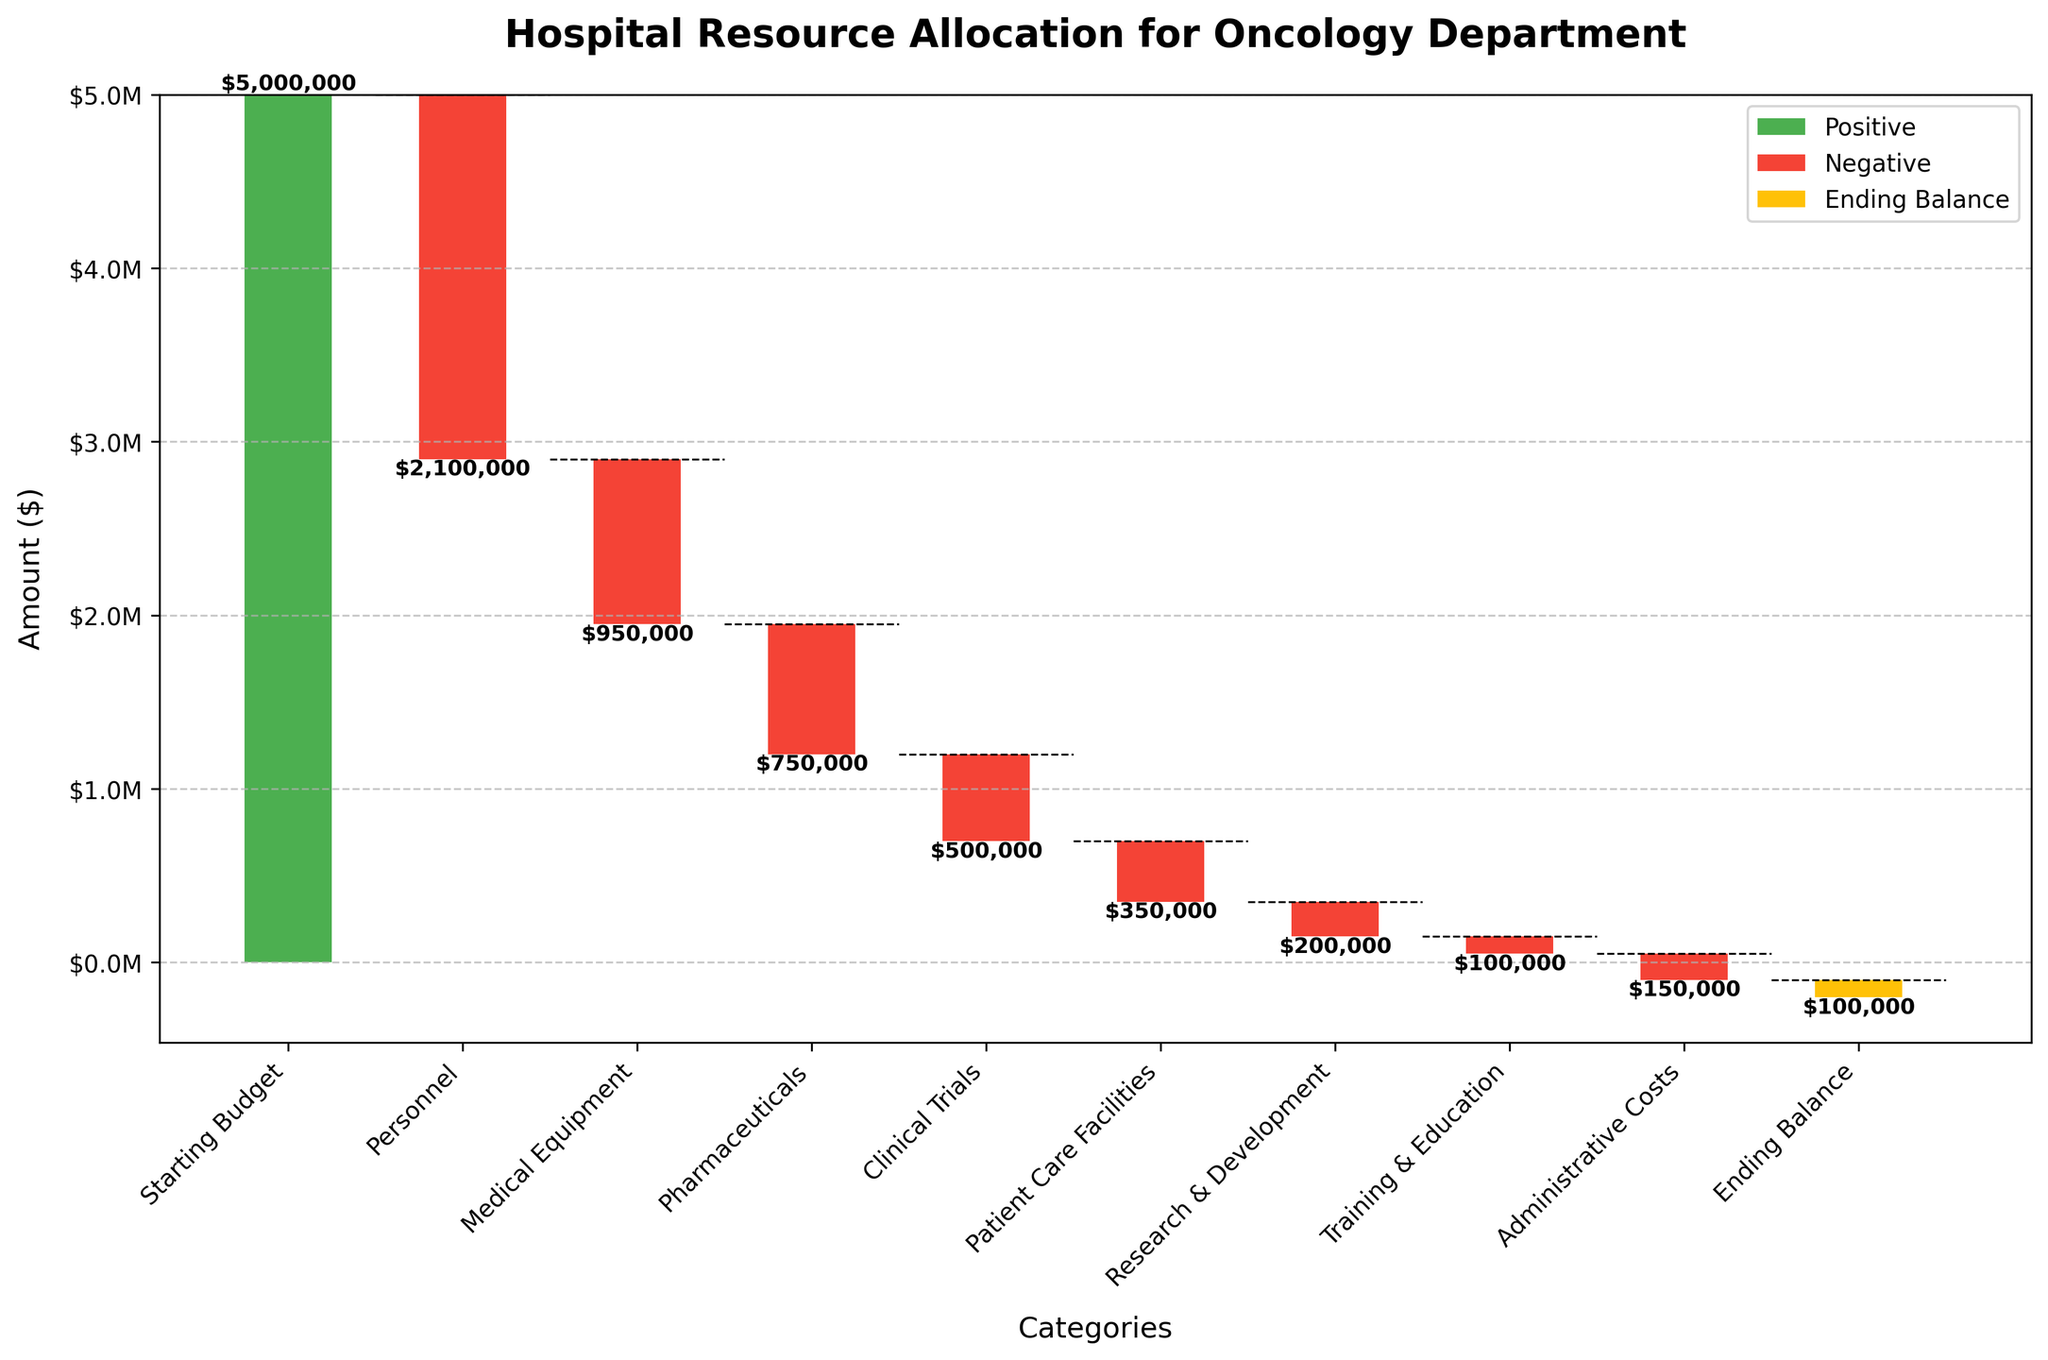What is the title of the Waterfall Chart? The title is clearly written at the top of the chart in a bold font. It summarizes the main topic of the chart, which is the allocation of resources in the hospital's oncology department.
Answer: Hospital Resource Allocation for Oncology Department What is the starting budget amount? The starting budget amount is the first bar on the left, which is labeled "Starting Budget" on the x-axis. The amount is written above the bar and marked in green color.
Answer: $5,000,000 How many expense categories are detailed in the chart? The expense categories can be counted as the bars between the "Starting Budget" and "Ending Balance" bars, each labeled individually on the x-axis.
Answer: 8 Which expense category has the highest cost? By comparing the heights of the bars and their corresponding labels, the "Personnel" category has the longest red bar indicating the highest cost.
Answer: Personnel What is the cumulative impact on the budget after "Medical Equipment"? Cumulative impact can be found by summing the amounts up to the "Medical Equipment" bar. Starting at $5,000,000 and subtracting $2,100,000 for Personnel and $950,000 for Medical Equipment gives the cumulative total at this point.
Answer: $1,950,000 What is the color of the bars that represent negative values? Observing the colors used for visual differentiation, the bars representing negative values are in red color.
Answer: Red Which two categories combined have the same total expense as the "Medical Equipment" category? Summing different pairs of categories and comparing it to the "Medical Equipment" expense of $950,000. "Clinical Trials" ($500,000) and "Patient Care Facilities" ($350,000) together sum up to $850,000 which is not correct. The correct pair is "Pharmaceuticals" ($750,000) and "Training & Education" ($100,000), which sum to $850,000.
Answer: None exactly equal What is the total expense for "Research & Development" and "Training & Education" combined? Adding up the expenses for both categories: $200,000 for "Research & Development" and $100,000 for "Training & Education" results in the combined total expenditure.
Answer: $300,000 After all expenses, what is the ending balance? The ending balance is shown as the last bar on the right, labeled "Ending Balance." The yellow color indicates the final amount left, which is also written at the top of the bar.
Answer: -$100,000 